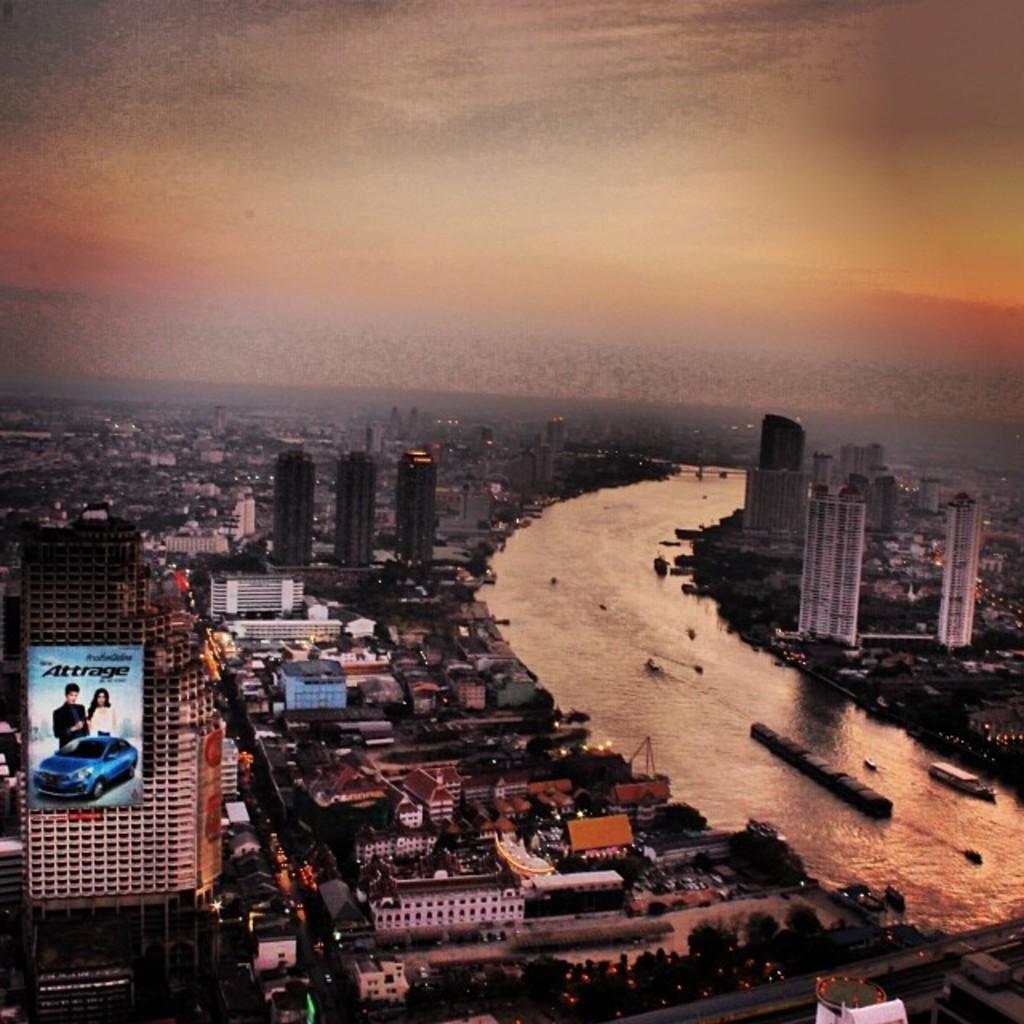Describe this image in one or two sentences. In this image I can see number of buildings, a board, water and in in water I can see few things. On this board I can see something is written and I can also see a blue car and few people. 